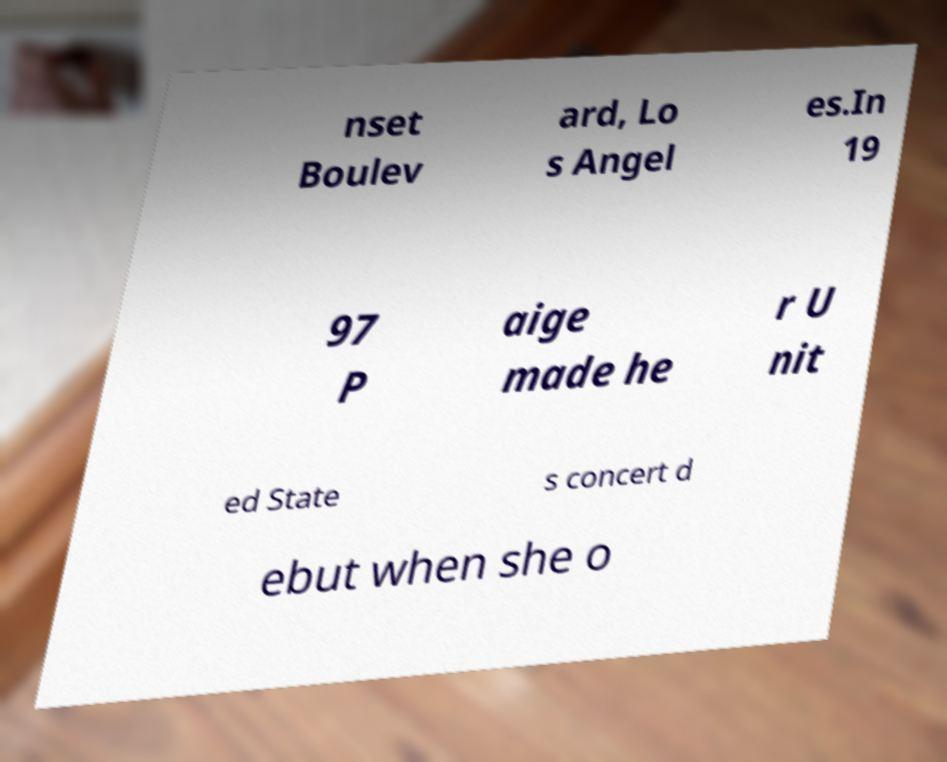Can you read and provide the text displayed in the image?This photo seems to have some interesting text. Can you extract and type it out for me? nset Boulev ard, Lo s Angel es.In 19 97 P aige made he r U nit ed State s concert d ebut when she o 